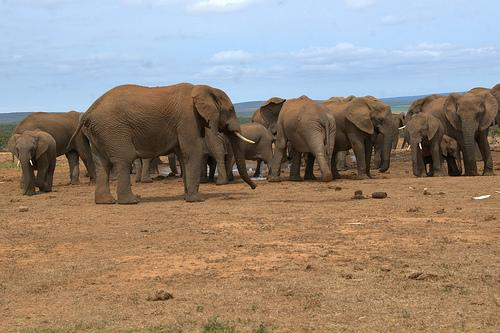Explain the image's setting, including the sky and the ground. The image takes place in a wild environment, with a clear blue sky that has several light blue clouds, making it seem nice and calm. The ground is a mix of trampled dirt, brown grass, and orange sandy soil, likely from the movement of the elephants. List five visible physical features of the elephants in this image. 5. Legs Discuss the presence of clouds in the sky and their appearance. The sky has several clouds that look light blue in color and are somewhat scattered throughout the sky. This gives the sky a partly cloudy appearance, which contributes to the calm atmosphere of the image. Explain the interactions between the multiple elephants in the picture. The elephants are huddled together, possibly interacting and providing a sense of security for each other. The baby elephant seems to be walking towards the camera, perhaps exploring its surroundings while staying close to the group. Describe the color variation in the sky and the emotions it evokes. The sky is a bluegreenish hue, with areas of light blue where clouds appear. This combination of shades creates a sense of calmness and peacefulness in the image. How many elephants can you count in the image? The exact number of elephants is not mentioned, but the description suggests that there are several elephants all together in the image. What are some noticeable elements of the ground beneath the feet of the elephants? The ground beneath the feet of the elephants has trampled dirt, patches of brown grass, orange sandy soil, and animal poop, possibly from the elephants themselves. Analyze the overall sentiment and mood of the image based on the descriptions. The image conveys a sense of calmness and peacefulness due to the clear sky with light blue clouds, as well as the natural setting where the elephants are gathered together, maintaining a sense of safety and unity within the group. In this image, comment on the attributes of an elephant's ear and trunk. In the image, the elephant's ear appears large and a bit floppy, while the trunk is long and slightly curved, which is typical of an elephant's anatomy. Provide a detailed description of the elephants in the image. The elephants are in a group, standing on trampled ground with patches of brown grass and orange sandy soil. They appear to be grey and brown, with wrinkled skin, big ears, long trunks, and tusks. There is a small elephant, possibly a baby, walking towards the camera. 